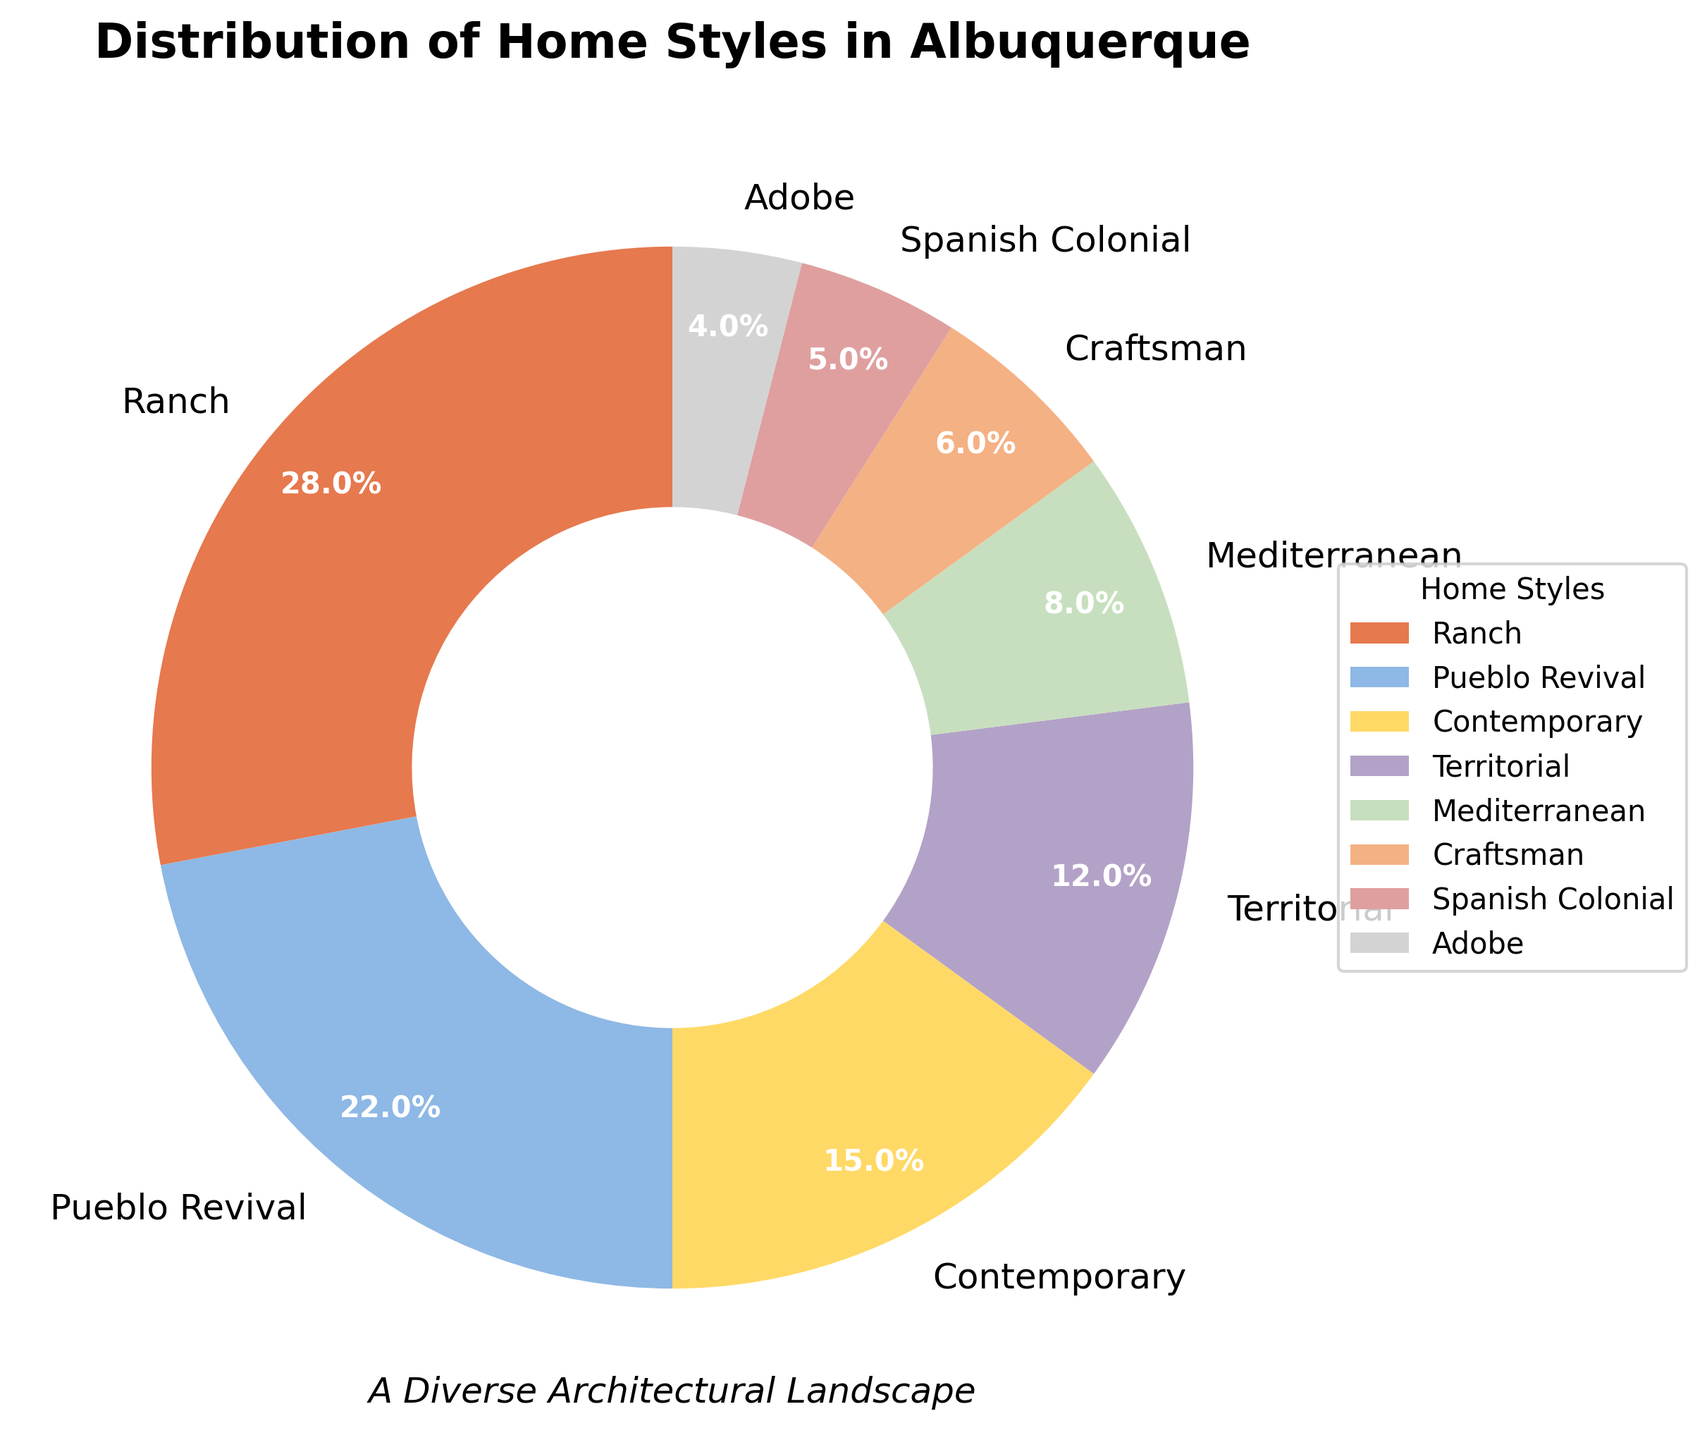What is the most common home style in Albuquerque? The pie chart shows the various home styles with their respective percentages. From the chart, the largest wedge corresponds to the "Ranch" home style.
Answer: Ranch Which home style has the second highest share after Ranch? After identifying Ranch as the largest wedge, we can see that the next largest wedge is labeled "Pueblo Revival."
Answer: Pueblo Revival How does the percentage of Mediterranean homes compare to Craftsman homes? The chart shows Mediterranean homes occupy 8%, while Craftsman homes occupy 6%. Comparing these values, Mediterranean homes have a larger percentage than Craftsman homes.
Answer: Mediterranean homes have a larger percentage What is the combined percentage of Adobe and Spanish Colonial homes? From the chart, the percentages for Adobe and Spanish Colonial homes are 4% and 5%, respectively. Adding these values, 4% + 5% = 9%.
Answer: 9% How much larger is the share of Ranch homes compared to Territorial homes? Ranch homes occupy 28% and Territorial homes occupy 12%. The difference is 28% - 12% = 16%.
Answer: 16% Are Contemporary homes more or less popular than Mediterranean homes? The chart shows Contemporary homes at 15% and Mediterranean homes at 8%. Contemporary homes have a higher percentage than Mediterranean homes.
Answer: More popular What percentage of homes are either Contemporary or Pueblo Revival? The chart shows Contemporary homes at 15% and Pueblo Revival homes at 22%. Adding these values, 15% + 22% = 37%.
Answer: 37% Which home styles together make up exactly half of the pie chart? Identifying the wedges, Ranch (28%) and Pueblo Revival (22%) when combined, give 28% + 22% = 50%.
Answer: Ranch and Pueblo Revival What are the colors used in the wedges for Ranch and Adobe homes? From the chart, the Ranch wedge is colored in a shade of orange, and the Adobe wedge is colored in a shade of gray.
Answer: Orange and gray By how much does the share of Craftsman homes differ from Territorial homes? The pie chart shows Craftsman homes are 6% and Territorial homes are 12%. The difference is 12% - 6% = 6%.
Answer: 6% 